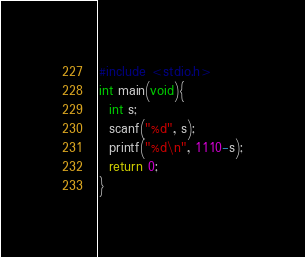Convert code to text. <code><loc_0><loc_0><loc_500><loc_500><_C_>#include <stdio.h>
int main(void){
  int s;
  scanf("%d", s);
  printf("%d\n", 1110-s);
  return 0;
}</code> 